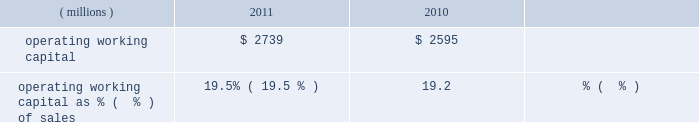Liquidity and capital resources during the past three years , we had sufficient financial resources to meet our operating requirements , to fund our capital spending , share repurchases and pension plans and to pay increasing dividends to our shareholders .
Cash from operating activities was $ 1436 million , $ 1310 million , and $ 1345 million in 2011 , 2010 , and 2009 , respectively .
Higher earnings increased cash from operations in 2011 compared to 2010 , but the increase was reduced by cash used to fund an increase in working capital of $ 212 million driven by our sales growth in 2011 .
Cash provided by working capital was greater in 2009 than 2010 and that decline was more than offset by the cash from higher 2010 earnings .
Operating working capital is a subset of total working capital and represents ( 1 ) trade receivables-net of the allowance for doubtful accounts , plus ( 2 ) inventories on a first-in , first-out ( 201cfifo 201d ) basis , less ( 3 ) trade creditors 2019 liabilities .
See note 3 , 201cworking capital detail 201d under item 8 of this form 10-k for further information related to the components of the company 2019s operating working capital .
We believe operating working capital represents the key components of working capital under the operating control of our businesses .
Operating working capital at december 31 , 2011 and 2010 was $ 2.7 billion and $ 2.6 billion , respectively .
A key metric we use to measure our working capital management is operating working capital as a percentage of sales ( fourth quarter sales annualized ) .
( millions ) 2011 2010 operating working capital $ 2739 $ 2595 operating working capital as % (  % ) of sales 19.5% ( 19.5 % ) 19.2% ( 19.2 % ) the change in operating working capital elements , excluding the impact of currency and acquisitions , was an increase of $ 195 million during the year ended december 31 , 2011 .
This increase was the net result of an increase in receivables from customers associated with the 2011 increase in sales and an increase in fifo inventory slightly offset by an increase in trade creditors 2019 liabilities .
Trade receivables from customers , net , as a percentage of fourth quarter sales , annualized , for 2011 was 17.9 percent , down slightly from 18.1 percent for 2010 .
Days sales outstanding was 66 days in 2011 , level with 2010 .
Inventories on a fifo basis as a percentage of fourth quarter sales , annualized , for 2011 was 13.1 percent level with 2010 .
Inventory turnover was 5.0 times in 2011 and 4.6 times in 2010 .
Total capital spending , including acquisitions , was $ 446 million , $ 341 million and $ 265 million in 2011 , 2010 , and 2009 , respectively .
Spending related to modernization and productivity improvements , expansion of existing businesses and environmental control projects was $ 390 million , $ 307 million and $ 239 million in 2011 , 2010 , and 2009 , respectively , and is expected to be in the range of $ 450-$ 550 million during 2012 .
Capital spending , excluding acquisitions , as a percentage of sales was 2.6% ( 2.6 % ) , 2.3% ( 2.3 % ) and 2.0% ( 2.0 % ) in 2011 , 2010 and 2009 , respectively .
Capital spending related to business acquisitions amounted to $ 56 million , $ 34 million , and $ 26 million in 2011 , 2010 and 2009 , respectively .
We continue to evaluate acquisition opportunities and expect to use cash in 2012 to fund small to mid-sized acquisitions , as part of a balanced deployment of our cash to support growth in earnings .
In january 2012 , the company closed the previously announced acquisitions of colpisa , a colombian producer of automotive oem and refinish coatings , and dyrup , a european architectural coatings company .
The cost of these acquisitions , including assumed debt , was $ 193 million .
Dividends paid to shareholders totaled $ 355 million , $ 360 million and $ 353 million in 2011 , 2010 and 2009 , respectively .
Ppg has paid uninterrupted annual dividends since 1899 , and 2011 marked the 40th consecutive year of increased annual dividend payments to shareholders .
We did not have a mandatory contribution to our u.s .
Defined benefit pension plans in 2011 ; however , we made voluntary contributions to these plans in 2011 totaling $ 50 million .
In 2010 and 2009 , we made voluntary contributions to our u.s .
Defined benefit pension plans of $ 250 and $ 360 million ( of which $ 100 million was made in ppg stock ) , respectively .
We expect to make voluntary contributions to our u.s .
Defined benefit pension plans in 2012 of up to $ 60 million .
Contributions were made to our non-u.s .
Defined benefit pension plans of $ 71 million , $ 87 million and $ 90 million ( of which approximately $ 20 million was made in ppg stock ) for 2011 , 2010 and 2009 , respectively , some of which were required by local funding requirements .
We expect to make mandatory contributions to our non-u.s .
Plans in 2012 of approximately $ 90 million .
The company 2019s share repurchase activity in 2011 , 2010 and 2009 was 10.2 million shares at a cost of $ 858 million , 8.1 million shares at a cost of $ 586 million and 1.5 million shares at a cost of $ 59 million , respectively .
We expect to make share repurchases in 2012 as part of our cash deployment focused on earnings growth .
The amount of spending will depend on the level of acquisition spending and other uses of cash , but we currently expect to spend in the range of $ 250 million to $ 500 million on share repurchases in 2012 .
We can repurchase about 9 million shares under the current authorization from the board of directors .
26 2011 ppg annual report and form 10-k .
Liquidity and capital resources during the past three years , we had sufficient financial resources to meet our operating requirements , to fund our capital spending , share repurchases and pension plans and to pay increasing dividends to our shareholders .
Cash from operating activities was $ 1436 million , $ 1310 million , and $ 1345 million in 2011 , 2010 , and 2009 , respectively .
Higher earnings increased cash from operations in 2011 compared to 2010 , but the increase was reduced by cash used to fund an increase in working capital of $ 212 million driven by our sales growth in 2011 .
Cash provided by working capital was greater in 2009 than 2010 and that decline was more than offset by the cash from higher 2010 earnings .
Operating working capital is a subset of total working capital and represents ( 1 ) trade receivables-net of the allowance for doubtful accounts , plus ( 2 ) inventories on a first-in , first-out ( 201cfifo 201d ) basis , less ( 3 ) trade creditors 2019 liabilities .
See note 3 , 201cworking capital detail 201d under item 8 of this form 10-k for further information related to the components of the company 2019s operating working capital .
We believe operating working capital represents the key components of working capital under the operating control of our businesses .
Operating working capital at december 31 , 2011 and 2010 was $ 2.7 billion and $ 2.6 billion , respectively .
A key metric we use to measure our working capital management is operating working capital as a percentage of sales ( fourth quarter sales annualized ) .
( millions ) 2011 2010 operating working capital $ 2739 $ 2595 operating working capital as % (  % ) of sales 19.5% ( 19.5 % ) 19.2% ( 19.2 % ) the change in operating working capital elements , excluding the impact of currency and acquisitions , was an increase of $ 195 million during the year ended december 31 , 2011 .
This increase was the net result of an increase in receivables from customers associated with the 2011 increase in sales and an increase in fifo inventory slightly offset by an increase in trade creditors 2019 liabilities .
Trade receivables from customers , net , as a percentage of fourth quarter sales , annualized , for 2011 was 17.9 percent , down slightly from 18.1 percent for 2010 .
Days sales outstanding was 66 days in 2011 , level with 2010 .
Inventories on a fifo basis as a percentage of fourth quarter sales , annualized , for 2011 was 13.1 percent level with 2010 .
Inventory turnover was 5.0 times in 2011 and 4.6 times in 2010 .
Total capital spending , including acquisitions , was $ 446 million , $ 341 million and $ 265 million in 2011 , 2010 , and 2009 , respectively .
Spending related to modernization and productivity improvements , expansion of existing businesses and environmental control projects was $ 390 million , $ 307 million and $ 239 million in 2011 , 2010 , and 2009 , respectively , and is expected to be in the range of $ 450-$ 550 million during 2012 .
Capital spending , excluding acquisitions , as a percentage of sales was 2.6% ( 2.6 % ) , 2.3% ( 2.3 % ) and 2.0% ( 2.0 % ) in 2011 , 2010 and 2009 , respectively .
Capital spending related to business acquisitions amounted to $ 56 million , $ 34 million , and $ 26 million in 2011 , 2010 and 2009 , respectively .
We continue to evaluate acquisition opportunities and expect to use cash in 2012 to fund small to mid-sized acquisitions , as part of a balanced deployment of our cash to support growth in earnings .
In january 2012 , the company closed the previously announced acquisitions of colpisa , a colombian producer of automotive oem and refinish coatings , and dyrup , a european architectural coatings company .
The cost of these acquisitions , including assumed debt , was $ 193 million .
Dividends paid to shareholders totaled $ 355 million , $ 360 million and $ 353 million in 2011 , 2010 and 2009 , respectively .
Ppg has paid uninterrupted annual dividends since 1899 , and 2011 marked the 40th consecutive year of increased annual dividend payments to shareholders .
We did not have a mandatory contribution to our u.s .
Defined benefit pension plans in 2011 ; however , we made voluntary contributions to these plans in 2011 totaling $ 50 million .
In 2010 and 2009 , we made voluntary contributions to our u.s .
Defined benefit pension plans of $ 250 and $ 360 million ( of which $ 100 million was made in ppg stock ) , respectively .
We expect to make voluntary contributions to our u.s .
Defined benefit pension plans in 2012 of up to $ 60 million .
Contributions were made to our non-u.s .
Defined benefit pension plans of $ 71 million , $ 87 million and $ 90 million ( of which approximately $ 20 million was made in ppg stock ) for 2011 , 2010 and 2009 , respectively , some of which were required by local funding requirements .
We expect to make mandatory contributions to our non-u.s .
Plans in 2012 of approximately $ 90 million .
The company 2019s share repurchase activity in 2011 , 2010 and 2009 was 10.2 million shares at a cost of $ 858 million , 8.1 million shares at a cost of $ 586 million and 1.5 million shares at a cost of $ 59 million , respectively .
We expect to make share repurchases in 2012 as part of our cash deployment focused on earnings growth .
The amount of spending will depend on the level of acquisition spending and other uses of cash , but we currently expect to spend in the range of $ 250 million to $ 500 million on share repurchases in 2012 .
We can repurchase about 9 million shares under the current authorization from the board of directors .
26 2011 ppg annual report and form 10-k .
What was the percentage change in cash from operating activities from 2010 to 2011? 
Computations: ((1436 - 1310) / 1310)
Answer: 0.09618. 